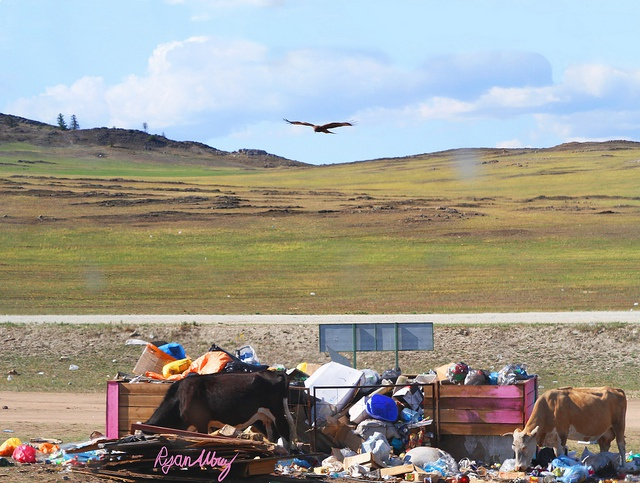Describe the objects in this image and their specific colors. I can see cow in lavender, maroon, gray, and tan tones, cow in lavender, black, maroon, and gray tones, and bird in lavender, black, maroon, darkgray, and lightblue tones in this image. 